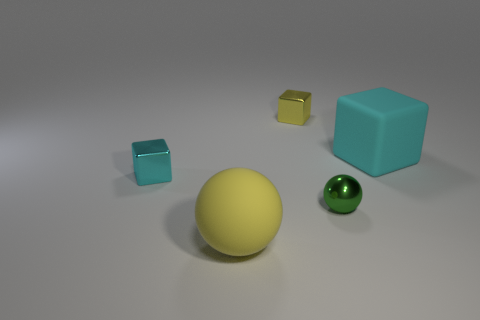Subtract all small cubes. How many cubes are left? 1 Add 3 small yellow blocks. How many objects exist? 8 Subtract all cyan cubes. How many cubes are left? 1 Subtract 3 blocks. How many blocks are left? 0 Subtract all cubes. How many objects are left? 2 Subtract all yellow matte spheres. Subtract all small gray shiny things. How many objects are left? 4 Add 1 spheres. How many spheres are left? 3 Add 4 balls. How many balls exist? 6 Subtract 0 cyan balls. How many objects are left? 5 Subtract all cyan spheres. Subtract all red cylinders. How many spheres are left? 2 